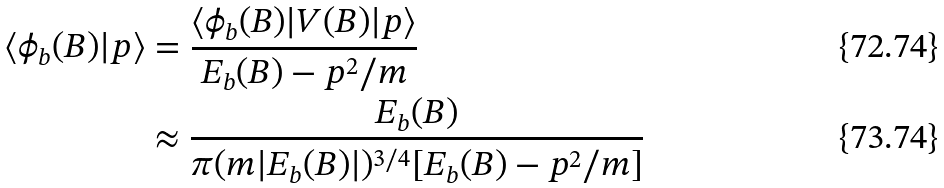Convert formula to latex. <formula><loc_0><loc_0><loc_500><loc_500>\langle \phi _ { b } ( B ) | p \rangle & = \frac { \langle \phi _ { b } ( B ) | V ( B ) | p \rangle } { E _ { b } ( B ) - p ^ { 2 } / m } \\ & \approx \frac { E _ { b } ( B ) } { \pi ( m | E _ { b } ( B ) | ) ^ { 3 / 4 } [ E _ { b } ( B ) - p ^ { 2 } / m ] }</formula> 